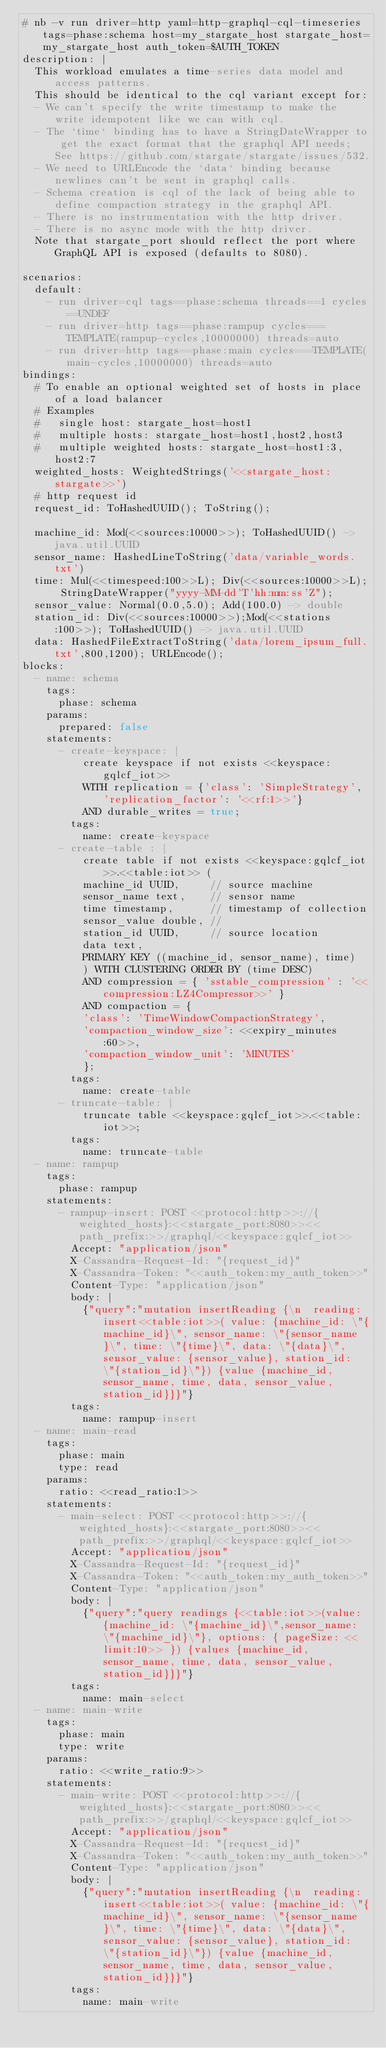Convert code to text. <code><loc_0><loc_0><loc_500><loc_500><_YAML_># nb -v run driver=http yaml=http-graphql-cql-timeseries tags=phase:schema host=my_stargate_host stargate_host=my_stargate_host auth_token=$AUTH_TOKEN
description: |
  This workload emulates a time-series data model and access patterns.
  This should be identical to the cql variant except for:
  - We can't specify the write timestamp to make the write idempotent like we can with cql.
  - The `time` binding has to have a StringDateWrapper to get the exact format that the graphql API needs; See https://github.com/stargate/stargate/issues/532.
  - We need to URLEncode the `data` binding because newlines can't be sent in graphql calls.
  - Schema creation is cql of the lack of being able to define compaction strategy in the graphql API.
  - There is no instrumentation with the http driver.
  - There is no async mode with the http driver.
  Note that stargate_port should reflect the port where GraphQL API is exposed (defaults to 8080).

scenarios:
  default:
    - run driver=cql tags==phase:schema threads==1 cycles==UNDEF
    - run driver=http tags==phase:rampup cycles===TEMPLATE(rampup-cycles,10000000) threads=auto
    - run driver=http tags==phase:main cycles===TEMPLATE(main-cycles,10000000) threads=auto
bindings:
  # To enable an optional weighted set of hosts in place of a load balancer
  # Examples
  #   single host: stargate_host=host1
  #   multiple hosts: stargate_host=host1,host2,host3
  #   multiple weighted hosts: stargate_host=host1:3,host2:7
  weighted_hosts: WeightedStrings('<<stargate_host:stargate>>')
  # http request id
  request_id: ToHashedUUID(); ToString();

  machine_id: Mod(<<sources:10000>>); ToHashedUUID() -> java.util.UUID
  sensor_name: HashedLineToString('data/variable_words.txt')
  time: Mul(<<timespeed:100>>L); Div(<<sources:10000>>L); StringDateWrapper("yyyy-MM-dd'T'hh:mm:ss'Z");
  sensor_value: Normal(0.0,5.0); Add(100.0) -> double
  station_id: Div(<<sources:10000>>);Mod(<<stations:100>>); ToHashedUUID() -> java.util.UUID
  data: HashedFileExtractToString('data/lorem_ipsum_full.txt',800,1200); URLEncode();
blocks:
  - name: schema
    tags:
      phase: schema
    params:
      prepared: false
    statements:
      - create-keyspace: |
          create keyspace if not exists <<keyspace:gqlcf_iot>>
          WITH replication = {'class': 'SimpleStrategy', 'replication_factor': '<<rf:1>>'}
          AND durable_writes = true;
        tags:
          name: create-keyspace
      - create-table : |
          create table if not exists <<keyspace:gqlcf_iot>>.<<table:iot>> (
          machine_id UUID,     // source machine
          sensor_name text,    // sensor name
          time timestamp,      // timestamp of collection
          sensor_value double, //
          station_id UUID,     // source location
          data text,
          PRIMARY KEY ((machine_id, sensor_name), time)
          ) WITH CLUSTERING ORDER BY (time DESC)
          AND compression = { 'sstable_compression' : '<<compression:LZ4Compressor>>' }
          AND compaction = {
          'class': 'TimeWindowCompactionStrategy',
          'compaction_window_size': <<expiry_minutes:60>>,
          'compaction_window_unit': 'MINUTES'
          };
        tags:
          name: create-table
      - truncate-table: |
          truncate table <<keyspace:gqlcf_iot>>.<<table:iot>>;
        tags:
          name: truncate-table
  - name: rampup
    tags:
      phase: rampup
    statements:
      - rampup-insert: POST <<protocol:http>>://{weighted_hosts}:<<stargate_port:8080>><<path_prefix:>>/graphql/<<keyspace:gqlcf_iot>>
        Accept: "application/json"
        X-Cassandra-Request-Id: "{request_id}"
        X-Cassandra-Token: "<<auth_token:my_auth_token>>"
        Content-Type: "application/json"
        body: |
          {"query":"mutation insertReading {\n  reading: insert<<table:iot>>( value: {machine_id: \"{machine_id}\", sensor_name: \"{sensor_name}\", time: \"{time}\", data: \"{data}\", sensor_value: {sensor_value}, station_id: \"{station_id}\"}) {value {machine_id, sensor_name, time, data, sensor_value, station_id}}}"}
        tags:
          name: rampup-insert
  - name: main-read
    tags:
      phase: main
      type: read
    params:
      ratio: <<read_ratio:1>>
    statements:
      - main-select: POST <<protocol:http>>://{weighted_hosts}:<<stargate_port:8080>><<path_prefix:>>/graphql/<<keyspace:gqlcf_iot>>
        Accept: "application/json"
        X-Cassandra-Request-Id: "{request_id}"
        X-Cassandra-Token: "<<auth_token:my_auth_token>>"
        Content-Type: "application/json"
        body: |
          {"query":"query readings {<<table:iot>>(value: {machine_id: \"{machine_id}\",sensor_name: \"{machine_id}\"}, options: { pageSize: <<limit:10>> }) {values {machine_id, sensor_name, time, data, sensor_value, station_id}}}"}
        tags:
          name: main-select
  - name: main-write
    tags:
      phase: main
      type: write
    params:
      ratio: <<write_ratio:9>>
    statements:
      - main-write: POST <<protocol:http>>://{weighted_hosts}:<<stargate_port:8080>><<path_prefix:>>/graphql/<<keyspace:gqlcf_iot>>
        Accept: "application/json"
        X-Cassandra-Request-Id: "{request_id}"
        X-Cassandra-Token: "<<auth_token:my_auth_token>>"
        Content-Type: "application/json"
        body: |
          {"query":"mutation insertReading {\n  reading: insert<<table:iot>>( value: {machine_id: \"{machine_id}\", sensor_name: \"{sensor_name}\", time: \"{time}\", data: \"{data}\", sensor_value: {sensor_value}, station_id: \"{station_id}\"}) {value {machine_id, sensor_name, time, data, sensor_value, station_id}}}"}
        tags:
          name: main-write
</code> 